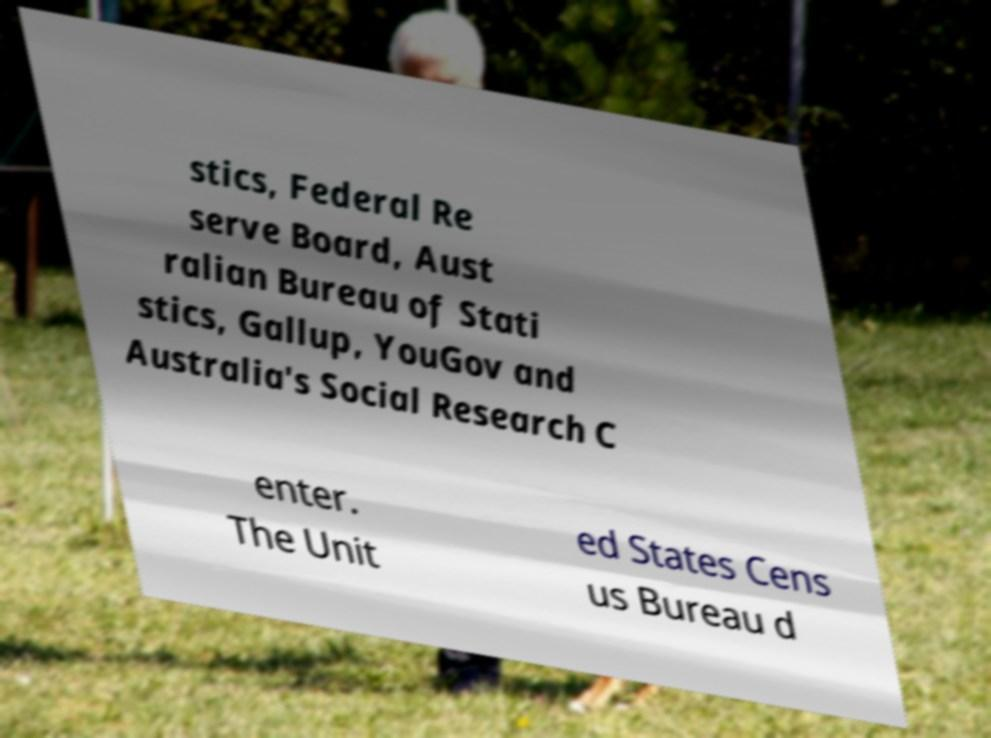There's text embedded in this image that I need extracted. Can you transcribe it verbatim? stics, Federal Re serve Board, Aust ralian Bureau of Stati stics, Gallup, YouGov and Australia's Social Research C enter. The Unit ed States Cens us Bureau d 